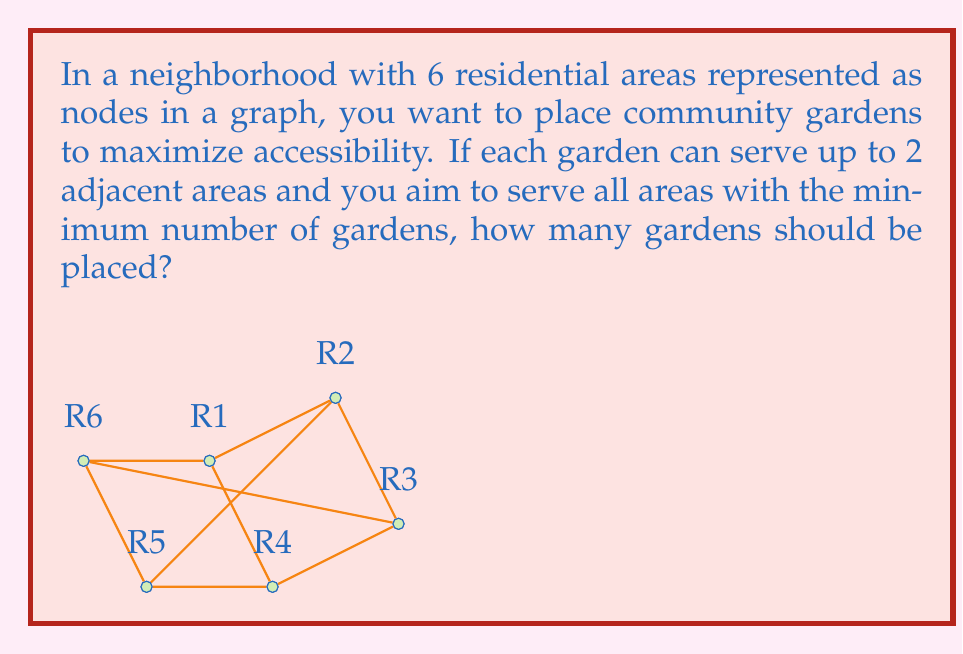Help me with this question. To solve this problem, we'll use the concept of vertex cover in graph theory:

1) First, we need to understand that each garden can serve up to 2 adjacent areas. This means we're looking for a set of nodes (gardens) that cover all edges in the graph.

2) The problem of finding the minimum number of gardens is equivalent to finding the minimum vertex cover of the graph.

3) For a cycle graph with 6 nodes, the minimum vertex cover is always $\left\lfloor\frac{n}{2}\right\rfloor$, where $n$ is the number of nodes.

4) In this case, $n = 6$, so:

   $$\left\lfloor\frac{6}{2}\right\rfloor = 3$$

5) We can verify this by placing gardens at alternate nodes (e.g., R1, R3, R5). This configuration covers all edges, ensuring each residential area is served by at least one garden.

6) Any fewer than 3 gardens would leave some edges (and thus some residential areas) uncovered.

Therefore, the minimum number of gardens needed to serve all 6 residential areas is 3.
Answer: 3 gardens 